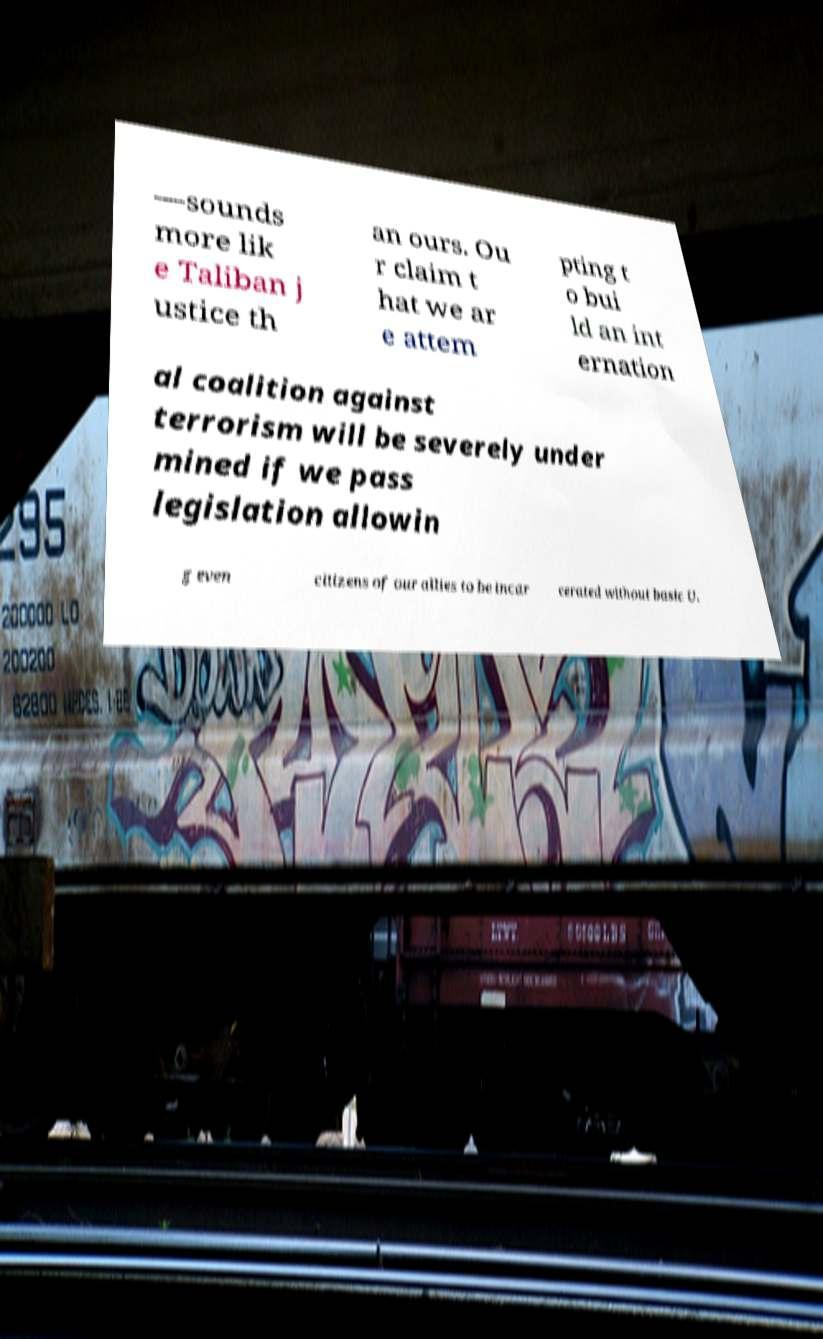For documentation purposes, I need the text within this image transcribed. Could you provide that? —sounds more lik e Taliban j ustice th an ours. Ou r claim t hat we ar e attem pting t o bui ld an int ernation al coalition against terrorism will be severely under mined if we pass legislation allowin g even citizens of our allies to be incar cerated without basic U. 